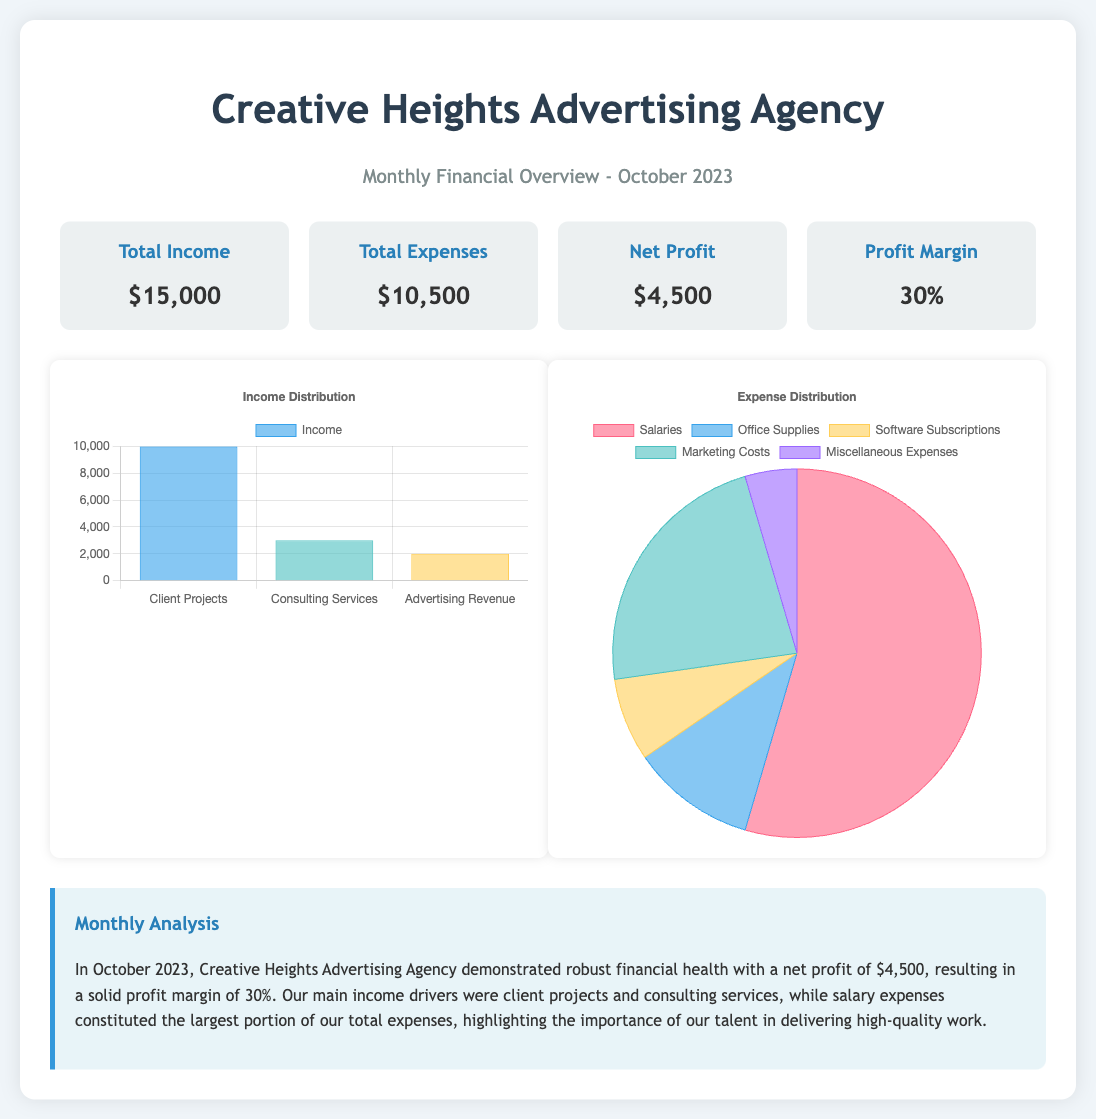what was the total income for October 2023? The total income for October 2023 is specified in the document as $15,000.
Answer: $15,000 what are the total expenses for October 2023? The total expenses for October 2023 are given as $10,500 in the document.
Answer: $10,500 what is the net profit for the agency? The net profit is derived from the total income minus total expenses, reported as $4,500 in the document.
Answer: $4,500 what is the profit margin percentage? The profit margin is mentioned in the document as 30%.
Answer: 30% which source contributed the highest income? The highest income source noted in the chart is "Client Projects," which amounts to $10,000.
Answer: Client Projects what is the largest expense category? The largest expense category highlighted in the pie chart is "Salaries," amounting to $6,000.
Answer: Salaries how many expense categories are listed? The document lists five categories for expenses displayed in the pie chart.
Answer: Five what is the focus of the monthly analysis? The monthly analysis emphasizes the agency’s robust financial health and the importance of talent in delivering work.
Answer: Robust financial health what type of chart is used for income distribution? The chart depicting income distribution is a bar chart, as described in the document.
Answer: Bar what does the commentary highlight about salaries? The commentary mentions that salary expenses constitute the largest portion of total expenses, indicating their significance.
Answer: Largest portion of total expenses 